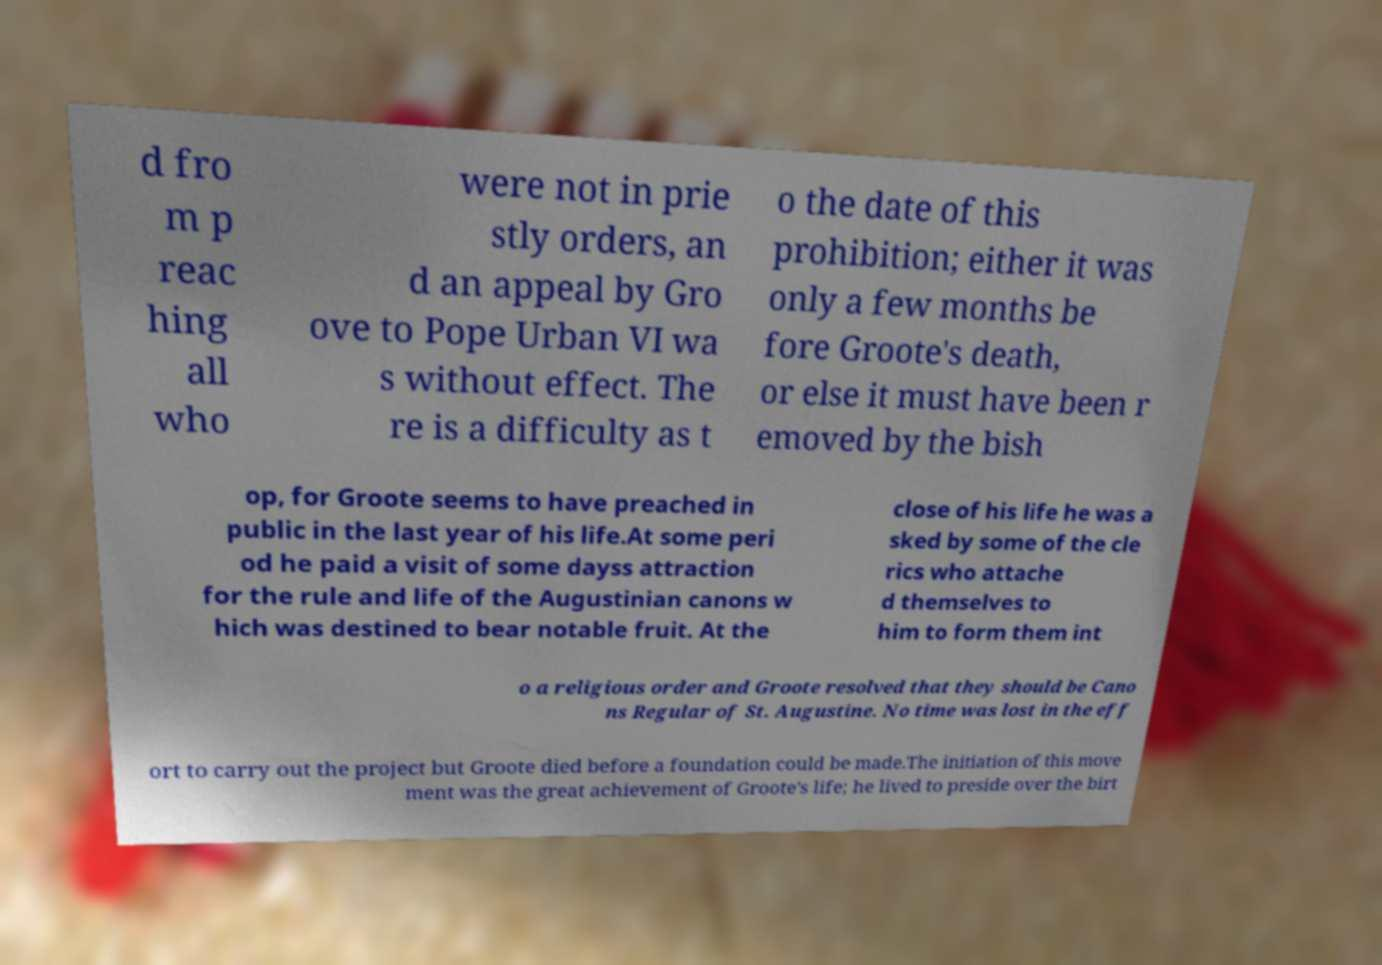Could you assist in decoding the text presented in this image and type it out clearly? d fro m p reac hing all who were not in prie stly orders, an d an appeal by Gro ove to Pope Urban VI wa s without effect. The re is a difficulty as t o the date of this prohibition; either it was only a few months be fore Groote's death, or else it must have been r emoved by the bish op, for Groote seems to have preached in public in the last year of his life.At some peri od he paid a visit of some dayss attraction for the rule and life of the Augustinian canons w hich was destined to bear notable fruit. At the close of his life he was a sked by some of the cle rics who attache d themselves to him to form them int o a religious order and Groote resolved that they should be Cano ns Regular of St. Augustine. No time was lost in the eff ort to carry out the project but Groote died before a foundation could be made.The initiation of this move ment was the great achievement of Groote's life; he lived to preside over the birt 